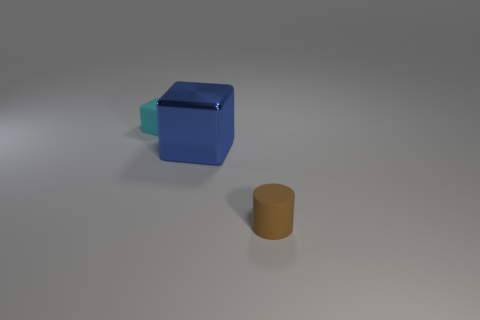Add 3 big yellow things. How many objects exist? 6 Subtract all blocks. How many objects are left? 1 Add 1 small cyan blocks. How many small cyan blocks exist? 2 Subtract 1 blue blocks. How many objects are left? 2 Subtract all big blue metallic blocks. Subtract all blue matte objects. How many objects are left? 2 Add 1 small rubber cylinders. How many small rubber cylinders are left? 2 